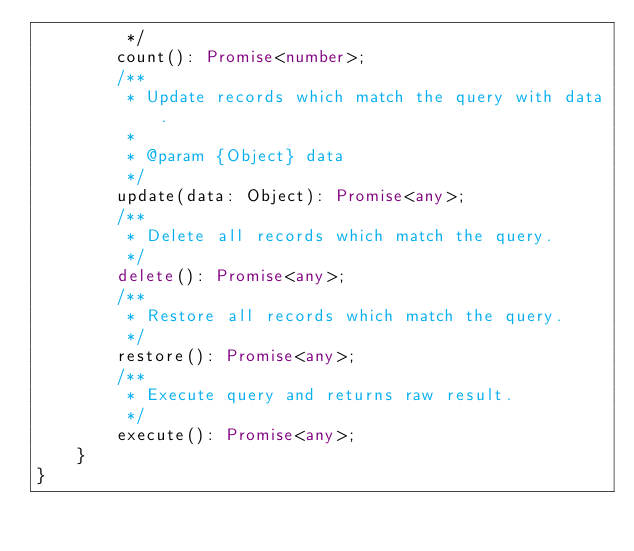<code> <loc_0><loc_0><loc_500><loc_500><_TypeScript_>         */
        count(): Promise<number>;
        /**
         * Update records which match the query with data.
         *
         * @param {Object} data
         */
        update(data: Object): Promise<any>;
        /**
         * Delete all records which match the query.
         */
        delete(): Promise<any>;
        /**
         * Restore all records which match the query.
         */
        restore(): Promise<any>;
        /**
         * Execute query and returns raw result.
         */
        execute(): Promise<any>;
    }
}
</code> 